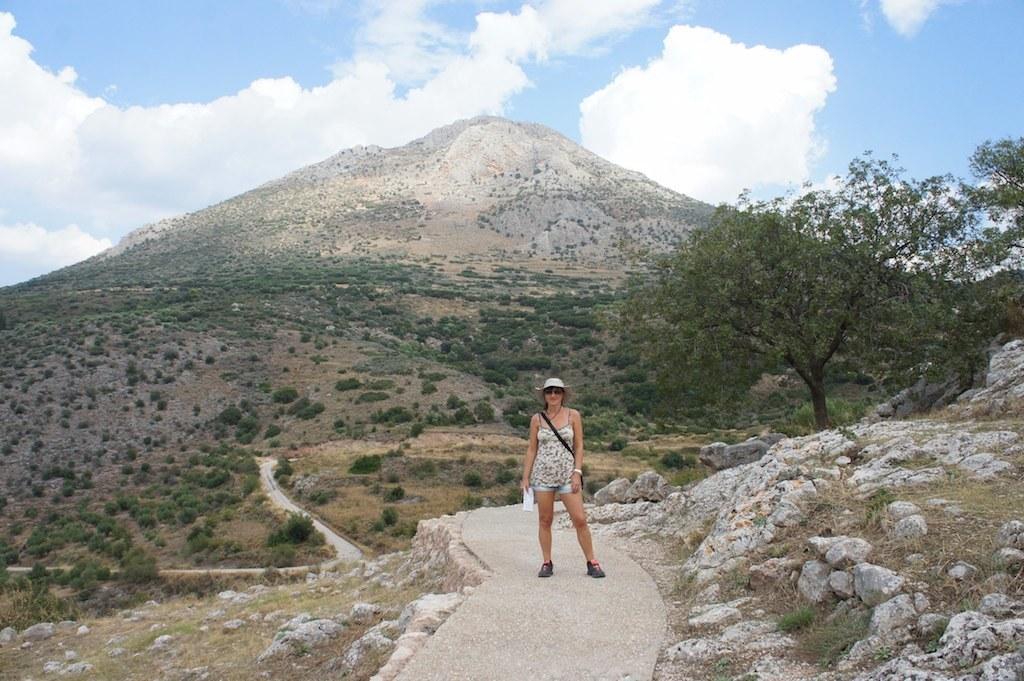Describe this image in one or two sentences. This is an outside view. Here I can see a woman standing on the road and giving pose for the picture. On both sides of the road there are rocks on the ground. On the right side there is a tree. In the background there are many trees and a hill. At the top of the image I can see the sky and clouds. 